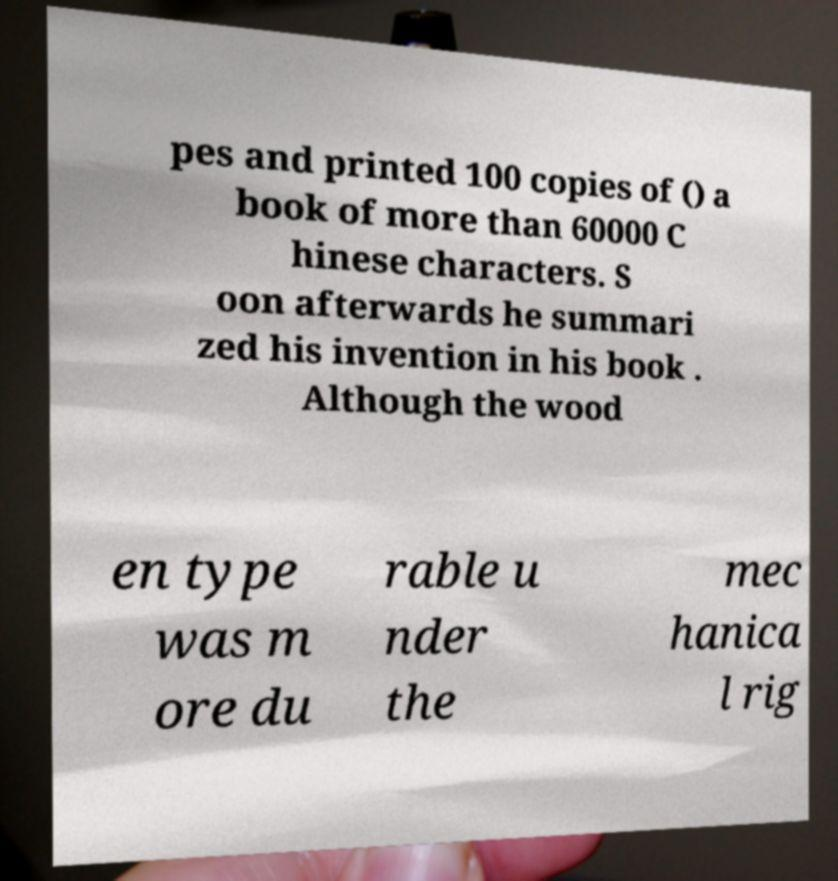Could you extract and type out the text from this image? pes and printed 100 copies of () a book of more than 60000 C hinese characters. S oon afterwards he summari zed his invention in his book . Although the wood en type was m ore du rable u nder the mec hanica l rig 